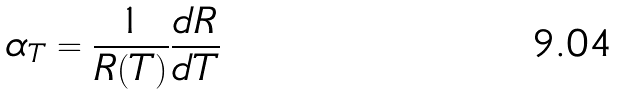Convert formula to latex. <formula><loc_0><loc_0><loc_500><loc_500>\alpha _ { T } = \frac { 1 } { R ( T ) } \frac { d R } { d T }</formula> 